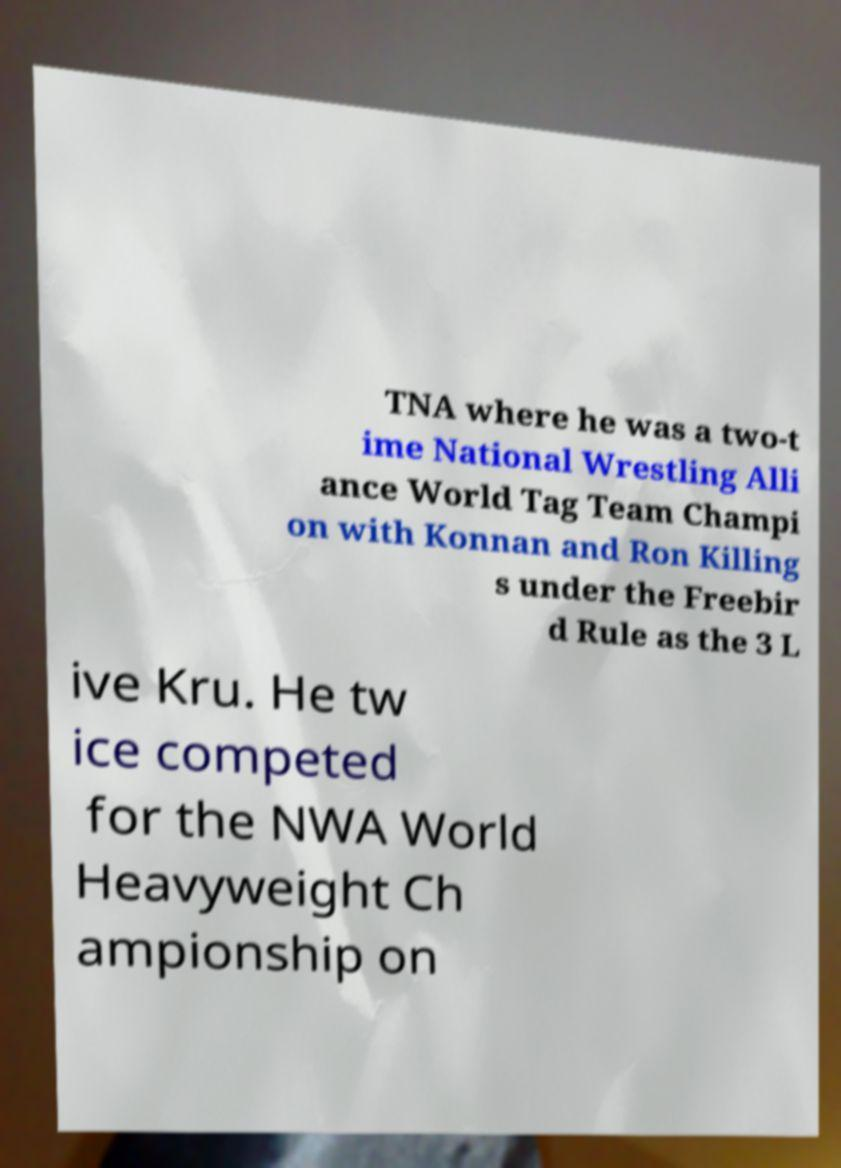Please identify and transcribe the text found in this image. TNA where he was a two-t ime National Wrestling Alli ance World Tag Team Champi on with Konnan and Ron Killing s under the Freebir d Rule as the 3 L ive Kru. He tw ice competed for the NWA World Heavyweight Ch ampionship on 